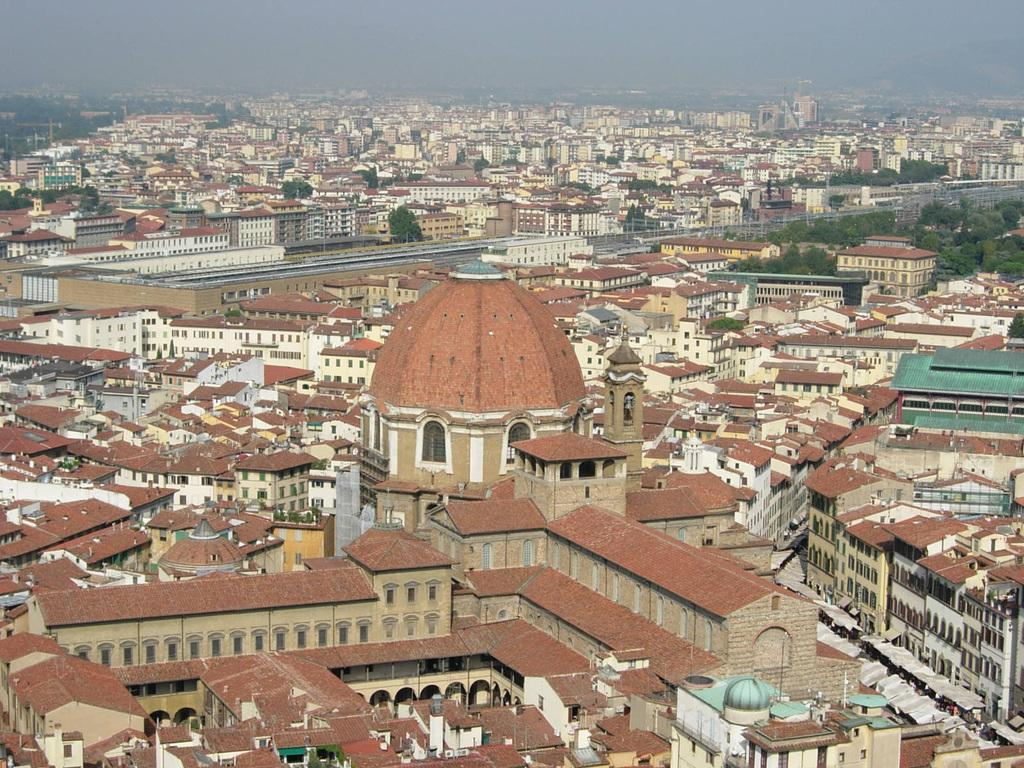What type of structures can be seen in the image? There are many buildings in the image. What colors are the buildings? The buildings are in multiple colors. What other natural elements are present in the image? There are trees in the image. What is the color of the trees? The trees are green. What is visible in the background of the image? The sky is visible in the image. What is the color of the sky? The sky is blue. Can you see a beggar asking for money in the image? There is no beggar present in the image. What type of jewel can be seen on top of the tallest building in the image? There are no jewels present in the image. 